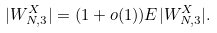Convert formula to latex. <formula><loc_0><loc_0><loc_500><loc_500>| W _ { N , 3 } ^ { X } | = ( 1 + o ( 1 ) ) E | W _ { N , 3 } ^ { X } | .</formula> 